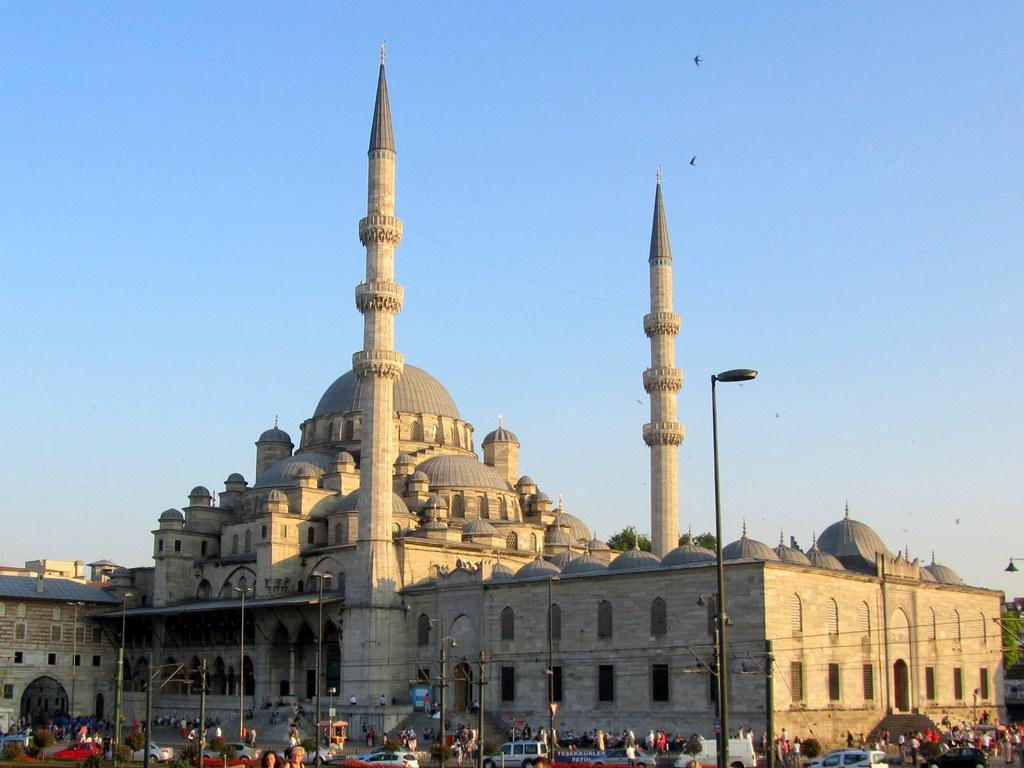Describe this image in one or two sentences. In this image I can see number of persons standing, few vehicles, few poles and few lights. I can see a huge building and in the background I can see the sky and few birds flying in the air. 